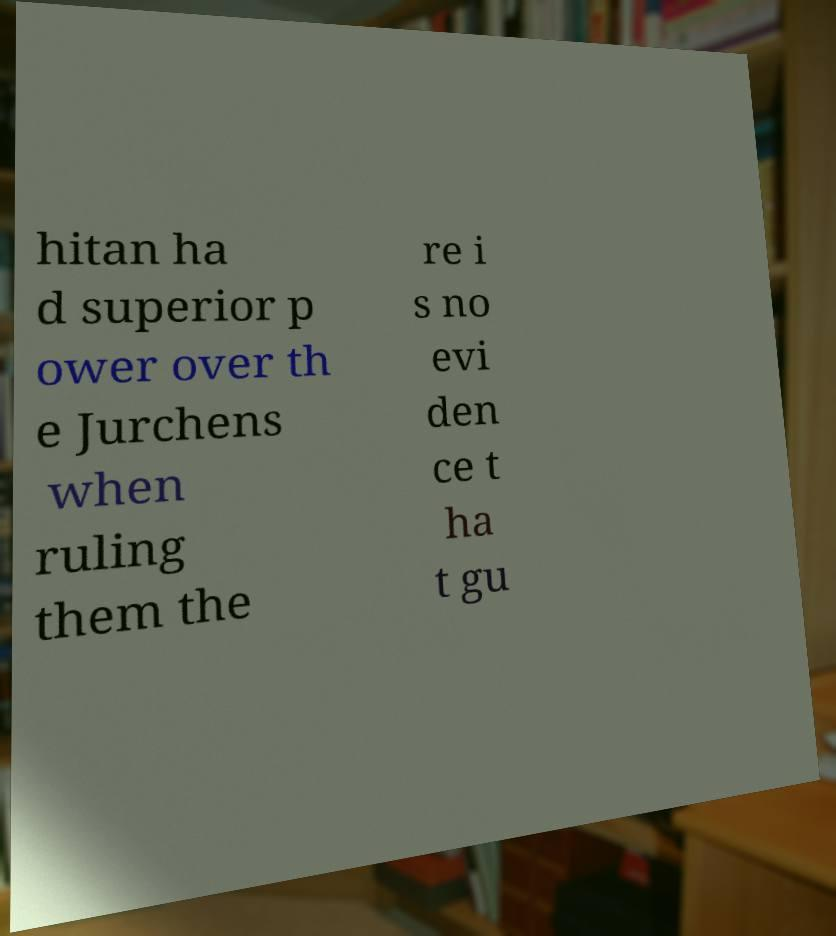Can you read and provide the text displayed in the image?This photo seems to have some interesting text. Can you extract and type it out for me? hitan ha d superior p ower over th e Jurchens when ruling them the re i s no evi den ce t ha t gu 